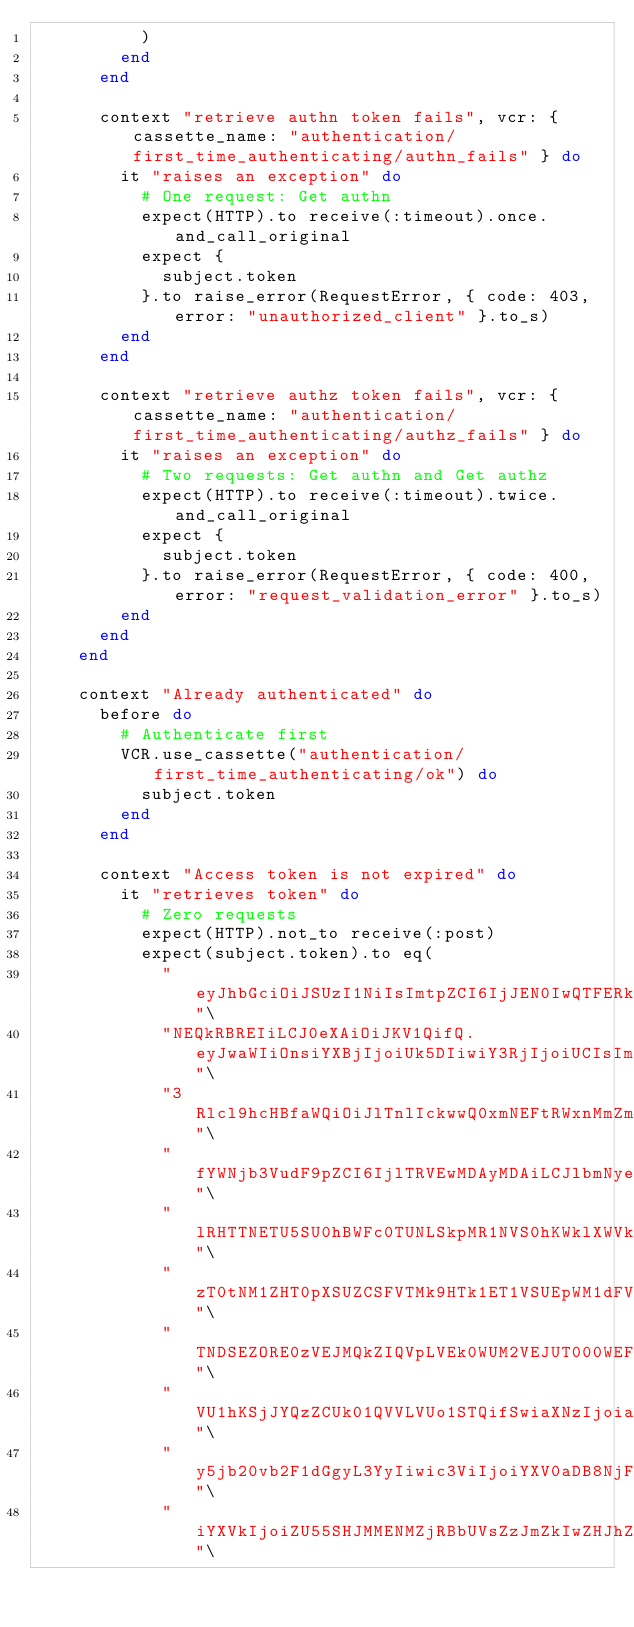Convert code to text. <code><loc_0><loc_0><loc_500><loc_500><_Ruby_>          )
        end
      end

      context "retrieve authn token fails", vcr: { cassette_name: "authentication/first_time_authenticating/authn_fails" } do
        it "raises an exception" do
          # One request: Get authn
          expect(HTTP).to receive(:timeout).once.and_call_original
          expect {
            subject.token
          }.to raise_error(RequestError, { code: 403, error: "unauthorized_client" }.to_s)
        end
      end

      context "retrieve authz token fails", vcr: { cassette_name: "authentication/first_time_authenticating/authz_fails" } do
        it "raises an exception" do
          # Two requests: Get authn and Get authz
          expect(HTTP).to receive(:timeout).twice.and_call_original
          expect {
            subject.token
          }.to raise_error(RequestError, { code: 400, error: "request_validation_error" }.to_s)
        end
      end
    end

    context "Already authenticated" do
      before do
        # Authenticate first
        VCR.use_cassette("authentication/first_time_authenticating/ok") do
          subject.token
        end
      end

      context "Access token is not expired" do
        it "retrieves token" do
          # Zero requests
          expect(HTTP).not_to receive(:post)
          expect(subject.token).to eq(
            "eyJhbGciOiJSUzI1NiIsImtpZCI6IjJEN0IwQTFERkJCNzlDRDFBQjM4NzNCMTcyODMyRjkxME"\
            "NEQkRBREIiLCJ0eXAiOiJKV1QifQ.eyJwaWIiOnsiYXBjIjoiUk5DIiwiY3RjIjoiUCIsIm1hc"\
            "3Rlcl9hcHBfaWQiOiJlTnlIckwwQ0xmNEFtRWxnMmZmQjBkcmFmYVVPTndjRyIsInNlcnZpY2V"\
            "fYWNjb3VudF9pZCI6IjlTRVEwMDAyMDAiLCJlbmNyeXB0ZWRfdG9rZW4iOiJJMDBfSlVZVE1OQ"\
            "lRHTTNETU5SU0hBWFc0TUNLSkpMR1NVS0hKWklXWVkyVE5VM0VHV0tHTVI0V1lSMlFLRlJESUs"\
            "zT0tNM1ZHT0pXSUZCSFVTMk9HTk1ET1VSUEpWM1dFVUNLTEJMRU8zMk9QQktHMjNSUUtWWUdTW"\
            "TNDSEZORE0zVEJMQkZIQVpLVEk0WUM2VEJUT000WEFWQlJPWkdWQTVMVE9OQlVPV0wyTEFaRVl"\
            "VU1hKSjJYQzZCUk01QVVLVUo1STQifSwiaXNzIjoiaHR0cHM6Ly9hY2NvdW50cy5kb3dqb25lc"\
            "y5jb20vb2F1dGgyL3YyIiwic3ViIjoiYXV0aDB8NjFiMjcyMGYxYzNiMjI1NmQ3ZTM1Mjc2Iiw"\
            "iYXVkIjoiZU55SHJMMENMZjRBbUVsZzJmZkIwZHJhZmFVT053Y0ciLCJhenAiOiJlTnlIckwwQ"\</code> 